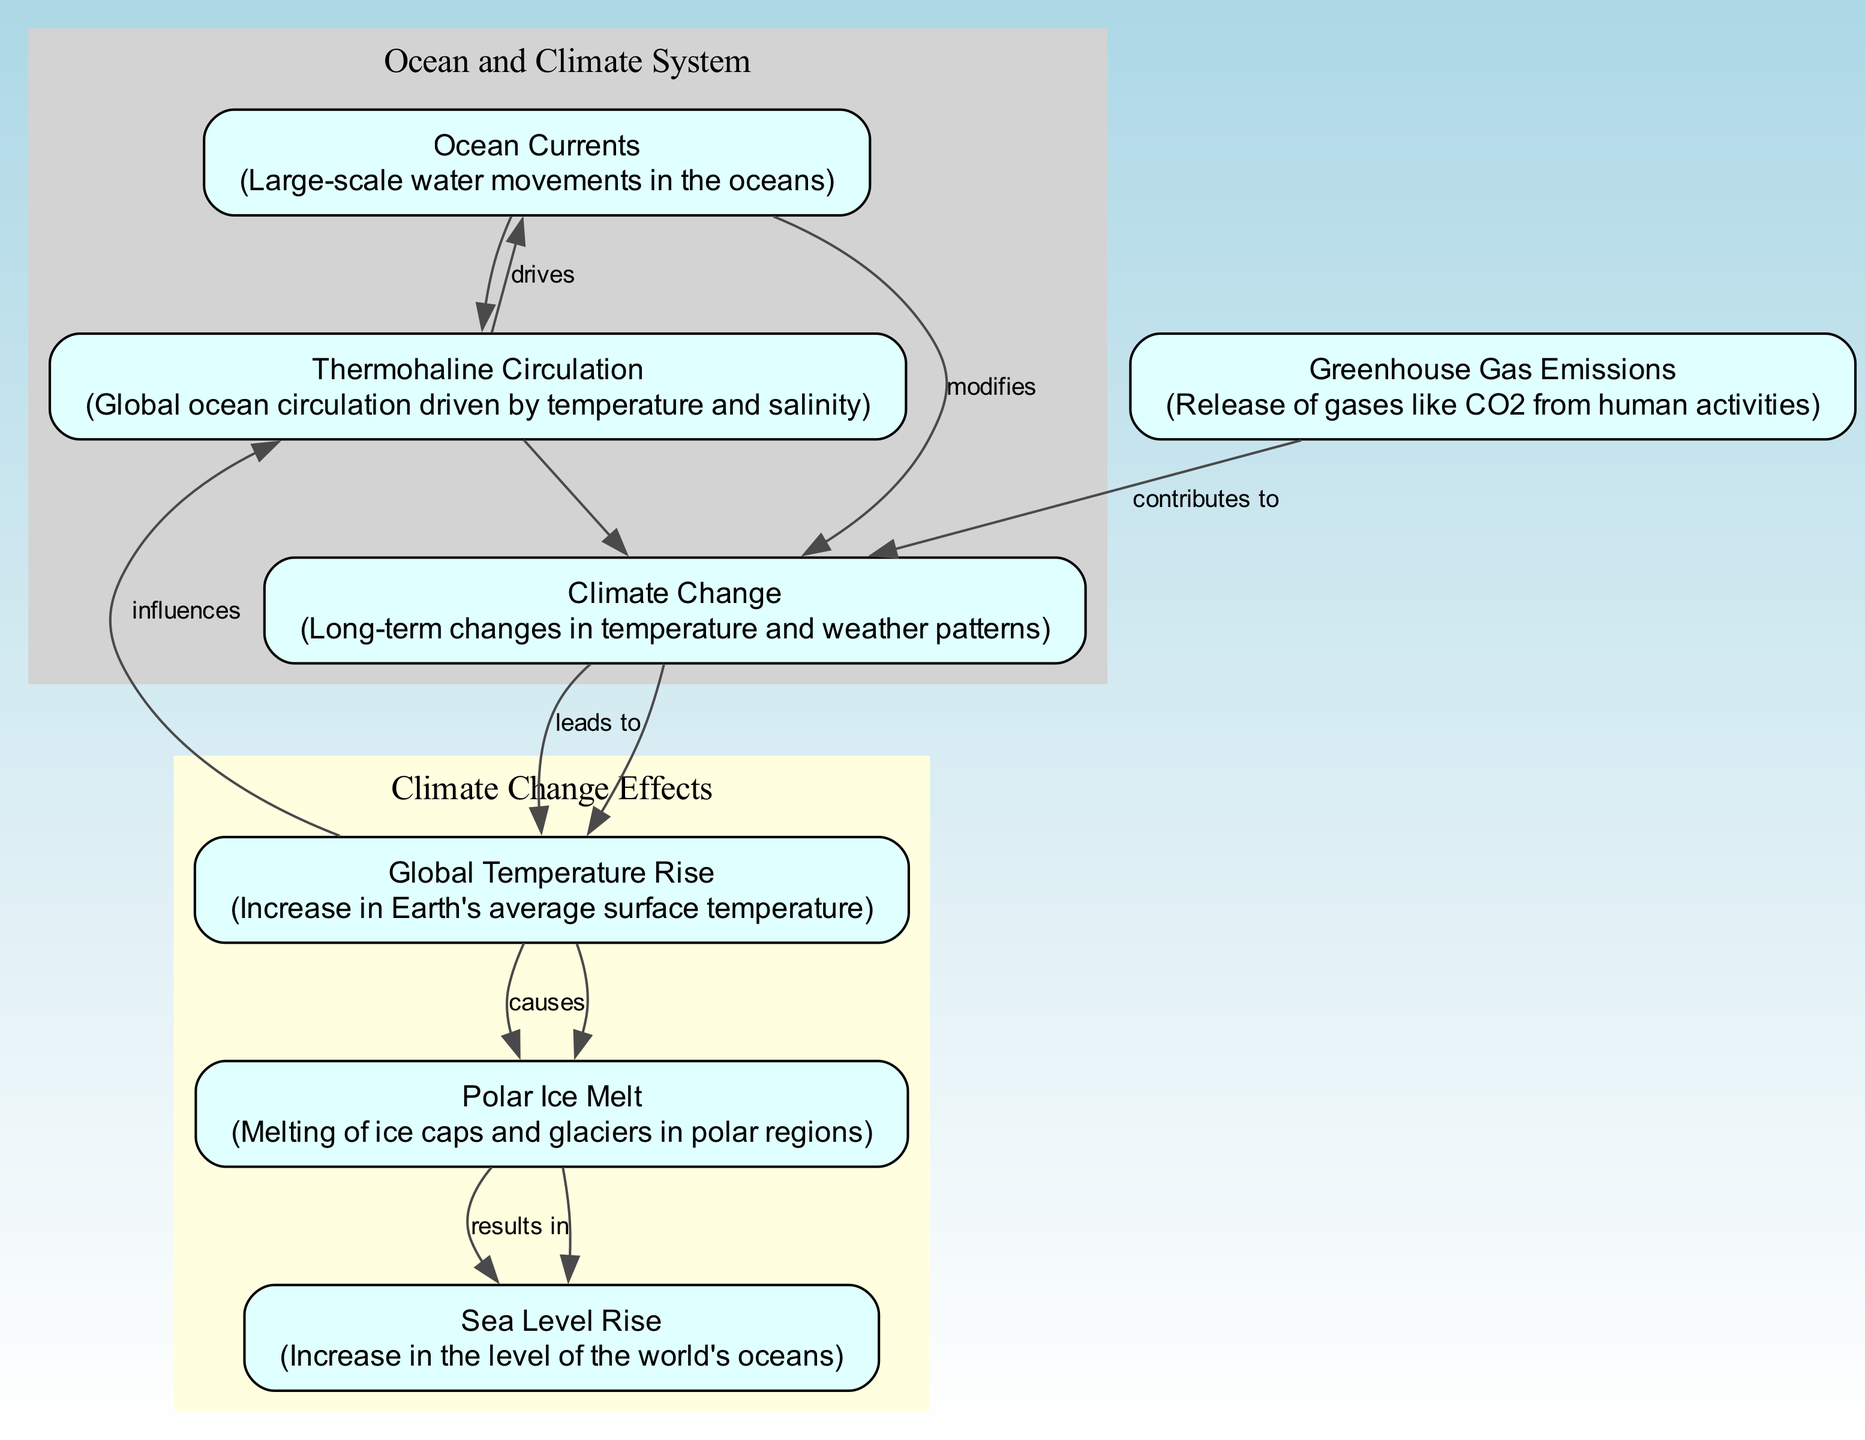What are the two main components illustrated in this diagram? The diagram includes nodes that represent "Ocean Currents" and "Climate Change" as the primary components. These are indicated clearly at the top of the diagram as significant elements contributing to the overall theme.
Answer: Ocean Currents, Climate Change How many nodes are there in total? Upon counting the nodes listed in the provided data, we see that there are 7 nodes in total: Ocean Currents, Climate Change, Thermohaline Circulation, Global Temperature Rise, Greenhouse Gas Emissions, Polar Ice Melt, and Sea Level Rise.
Answer: 7 Which element leads to Global Temperature Rise? The connection shown from "Climate Change" to "Global Temperature Rise" indicates that climate change is the factor that leads to an increase in global temperatures. This is explicitly labeled in the diagram.
Answer: Climate Change What causes Polar Ice Melt according to the diagram? The diagram indicates that "Global Temperature Rise" causes "Polar Ice Melt," establishing a direct connection between the two elements. This is represented by an arrow labeled "causes."
Answer: Global Temperature Rise How does Sea Level Rise relate to Polar Ice Melt? Based on the diagram, "Polar Ice Melt" results in "Sea Level Rise." This relationship is expressed through an arrow with a label indicating the cause-and-effect flow.
Answer: results in What effect do Ocean Currents have on Climate Change? The relationship depicted in the diagram shows that "Ocean Currents" modify "Climate Change." The direction of the arrow and the label suggest that the dynamics of ocean currents can influence or alter climate patterns.
Answer: modifies Describe the flow from Greenhouse Gas Emissions to Sea Level Rise. To understand this flow, we start from "Greenhouse Gas Emissions," which contributes to "Climate Change." This change leads to "Global Temperature Rise," which in turn causes "Polar Ice Melt," and finally results in "Sea Level Rise." The flow represents a sequence of consequences starting from human impact to physical environmental changes.
Answer: contributes to, leads to, causes, results in What is the role of Thermohaline Circulation in the context of the diagram? The diagram shows that "Global Temperature Rise" influences "Thermohaline Circulation," which then drives "Ocean Currents." This indicates that temperature changes can affect ocean circulation patterns that are vital for ecosystem dynamics and climate regulation.
Answer: influences, drives Why is it significant to study the relationship between Ocean Currents and Climate Change? The diagram illustrates that Ocean Currents not only play a critical role in driving climate processes but also are affected by climatic changes. Understanding this bidirectional relationship is essential as it highlights how both factors interconnect and impact global climate systems.
Answer: bidirectional relationship 